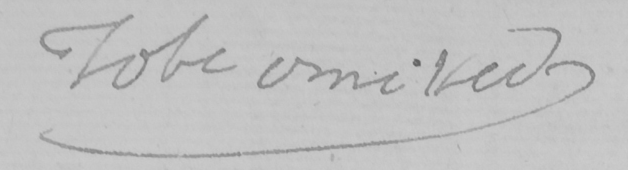Please provide the text content of this handwritten line. To be omitted 